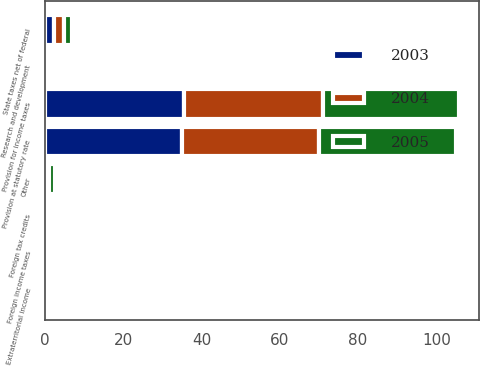<chart> <loc_0><loc_0><loc_500><loc_500><stacked_bar_chart><ecel><fcel>Provision at statutory rate<fcel>Foreign income taxes<fcel>Foreign tax credits<fcel>State taxes net of federal<fcel>Extraterritorial income<fcel>Research and development<fcel>Other<fcel>Provision for income taxes<nl><fcel>2003<fcel>35<fcel>0.1<fcel>0.1<fcel>2.3<fcel>0.6<fcel>0.6<fcel>0.2<fcel>35.5<nl><fcel>2004<fcel>35<fcel>0.1<fcel>0.1<fcel>2.5<fcel>0.7<fcel>0.5<fcel>0.8<fcel>35.5<nl><fcel>2005<fcel>35<fcel>0.1<fcel>0.1<fcel>2.1<fcel>0.5<fcel>0.5<fcel>1.4<fcel>34.7<nl></chart> 